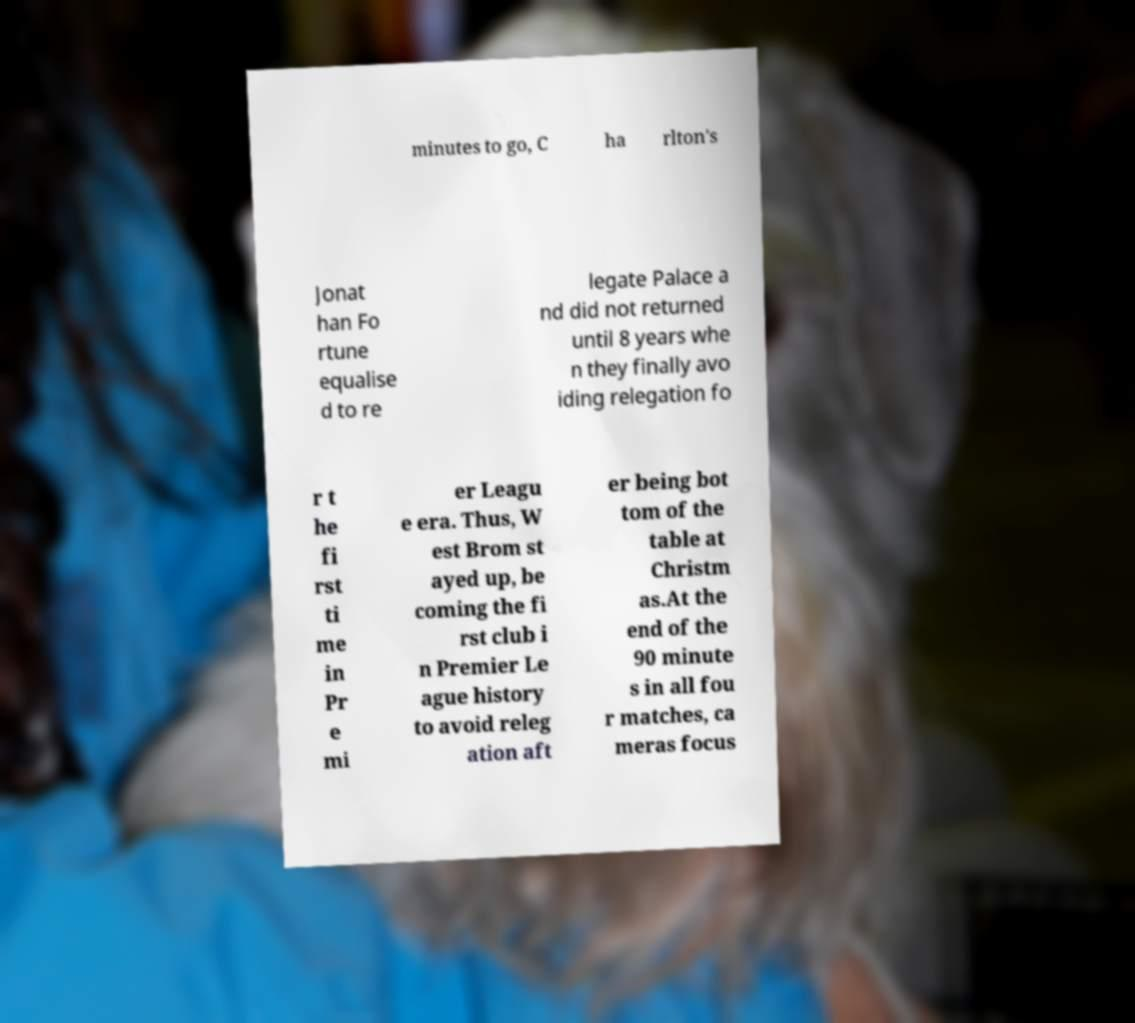For documentation purposes, I need the text within this image transcribed. Could you provide that? minutes to go, C ha rlton's Jonat han Fo rtune equalise d to re legate Palace a nd did not returned until 8 years whe n they finally avo iding relegation fo r t he fi rst ti me in Pr e mi er Leagu e era. Thus, W est Brom st ayed up, be coming the fi rst club i n Premier Le ague history to avoid releg ation aft er being bot tom of the table at Christm as.At the end of the 90 minute s in all fou r matches, ca meras focus 